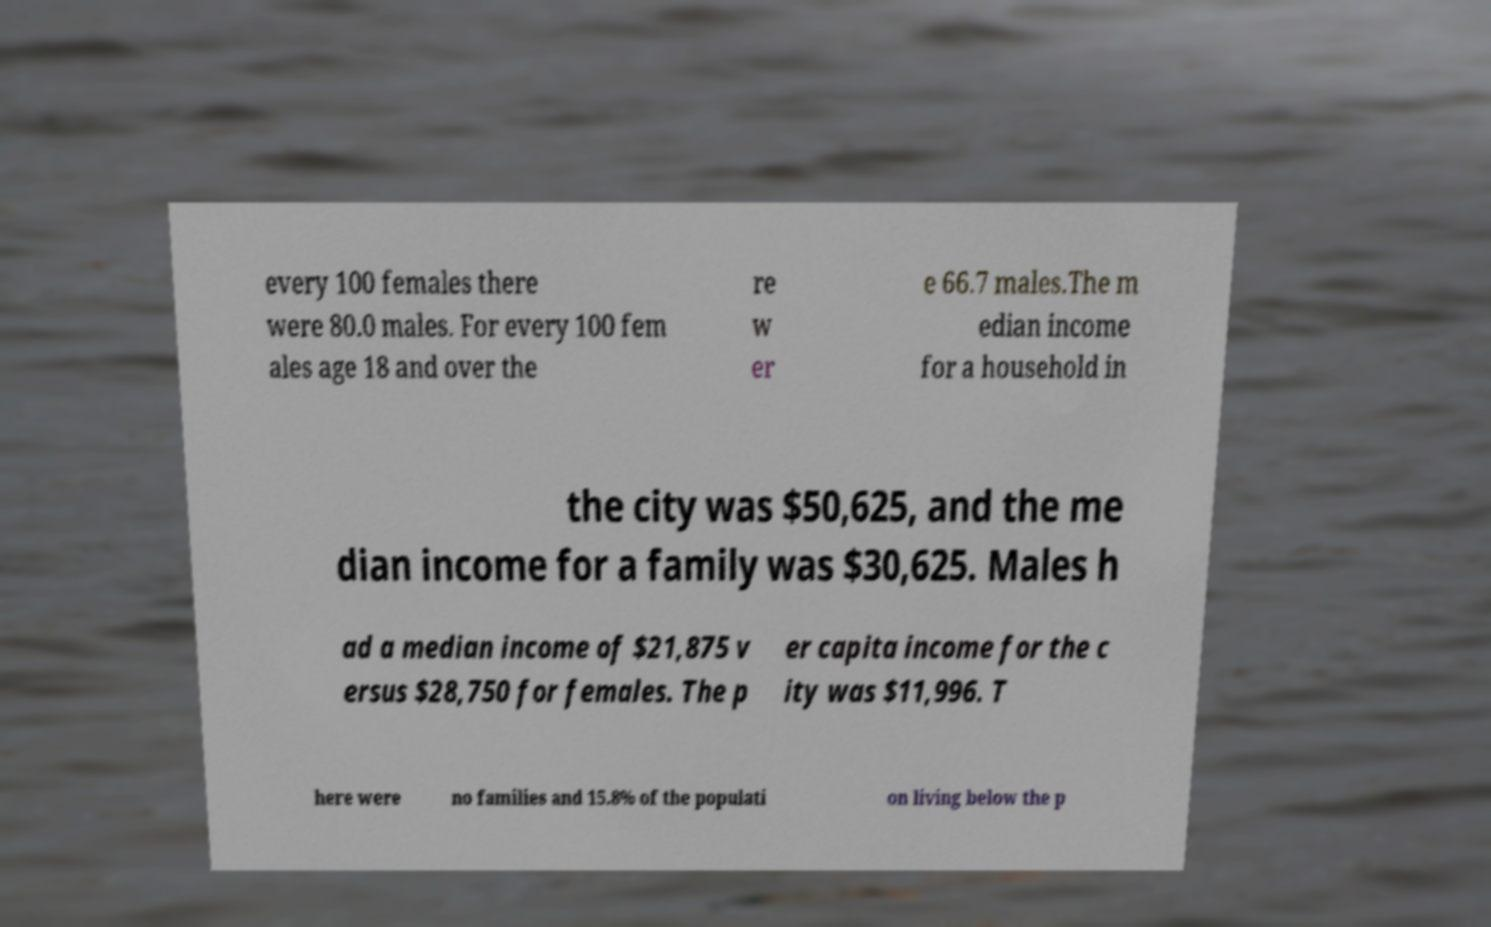Please identify and transcribe the text found in this image. every 100 females there were 80.0 males. For every 100 fem ales age 18 and over the re w er e 66.7 males.The m edian income for a household in the city was $50,625, and the me dian income for a family was $30,625. Males h ad a median income of $21,875 v ersus $28,750 for females. The p er capita income for the c ity was $11,996. T here were no families and 15.8% of the populati on living below the p 